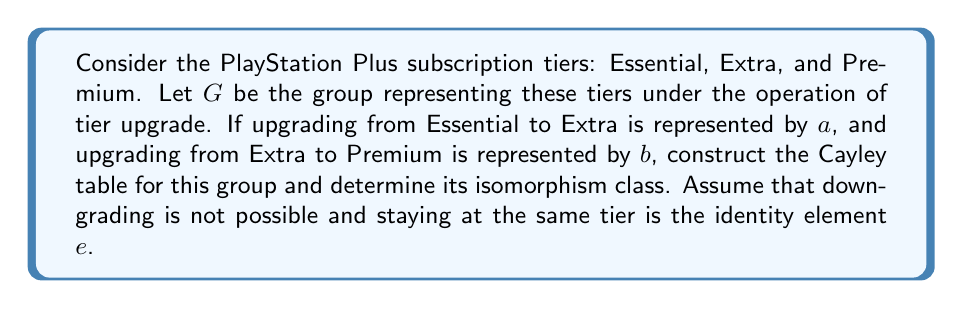Could you help me with this problem? To solve this problem, let's follow these steps:

1) First, let's identify the elements of the group $G$:
   $e$ : No change in tier (identity element)
   $a$ : Upgrade from Essential to Extra
   $b$ : Upgrade from Extra to Premium
   $ab$ : Upgrade from Essential to Premium

2) Now, let's construct the Cayley table for this group:

   $$\begin{array}{c|cccc}
   * & e & a & b & ab \\
   \hline
   e & e & a & b & ab \\
   a & a & e & ab & b \\
   b & b & ab & e & a \\
   ab & ab & b & a & e
   \end{array}$$

3) From this table, we can observe:
   - The group is closed under the operation
   - The operation is associative (as all finite groups are)
   - $e$ is the identity element
   - Each element has an inverse (e.g., $a*a=e$, $b*b=e$, $(ab)*(ab)=e$)

4) We can see that this group has order 4 and is non-abelian (because $a*b \neq b*a$).

5) The only non-abelian group of order 4 is the dihedral group $D_4$ (also known as the symmetry group of a square).

Therefore, the group $G$ is isomorphic to $D_4$.
Answer: The group $G$ representing PlayStation Plus subscription tiers under the upgrade operation is isomorphic to the dihedral group $D_4$. 